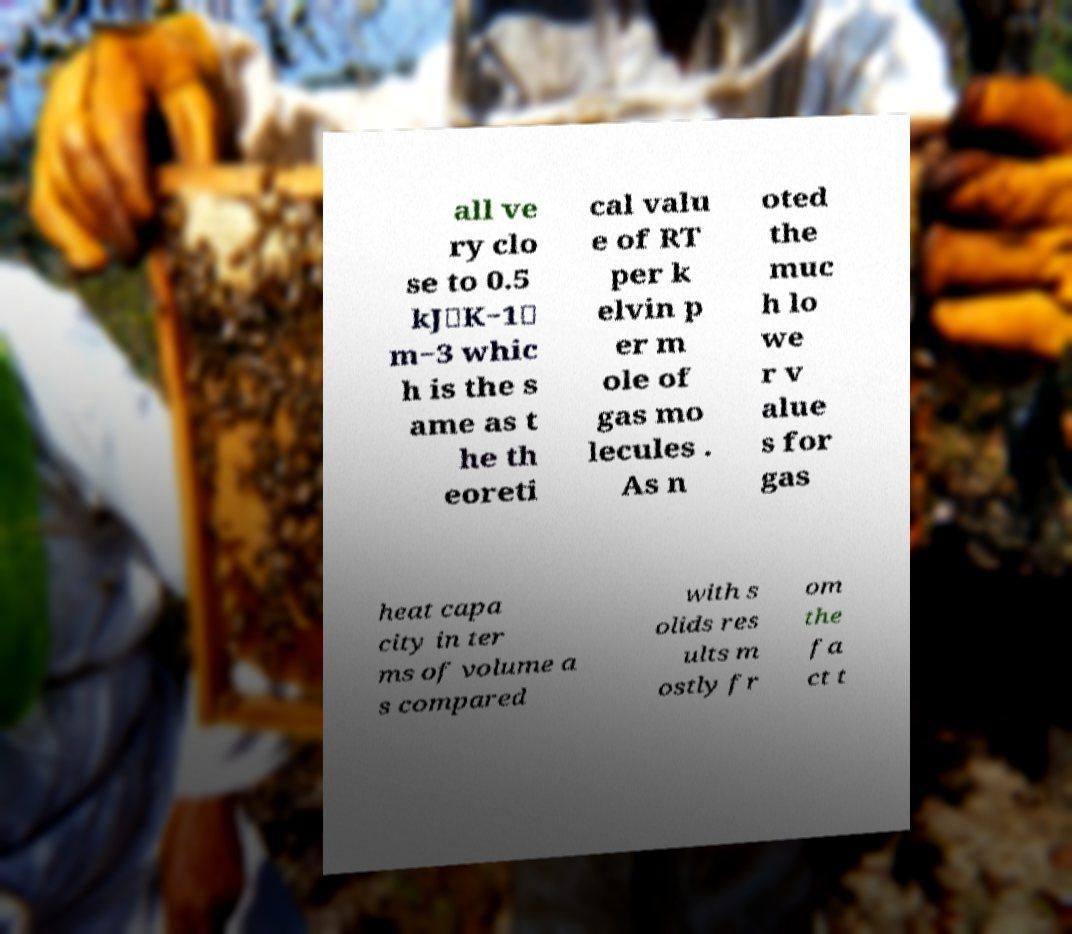Can you read and provide the text displayed in the image?This photo seems to have some interesting text. Can you extract and type it out for me? all ve ry clo se to 0.5 kJ⋅K−1⋅ m−3 whic h is the s ame as t he th eoreti cal valu e of RT per k elvin p er m ole of gas mo lecules . As n oted the muc h lo we r v alue s for gas heat capa city in ter ms of volume a s compared with s olids res ults m ostly fr om the fa ct t 